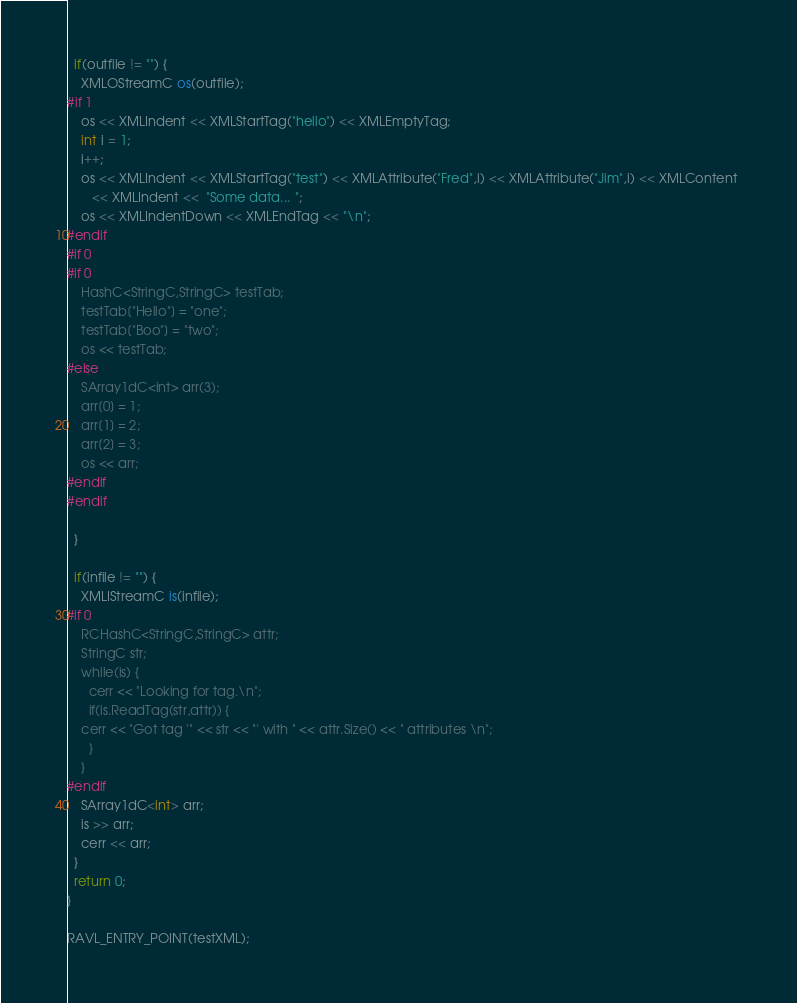<code> <loc_0><loc_0><loc_500><loc_500><_C++_>  if(outfile != "") {
    XMLOStreamC os(outfile);
#if 1
    os << XMLIndent << XMLStartTag("hello") << XMLEmptyTag;
    int i = 1;
    i++;
    os << XMLIndent << XMLStartTag("test") << XMLAttribute("Fred",i) << XMLAttribute("Jim",i) << XMLContent 
       << XMLIndent <<  "Some data... ";
    os << XMLIndentDown << XMLEndTag << "\n";
#endif    
#if 0
#if 0
    HashC<StringC,StringC> testTab;
    testTab["Hello"] = "one";
    testTab["Boo"] = "two";
    os << testTab;
#else
    SArray1dC<int> arr(3);
    arr[0] = 1;
    arr[1] = 2;
    arr[2] = 3;
    os << arr;
#endif
#endif

  }
  
  if(infile != "") {
    XMLIStreamC is(infile);
#if 0
    RCHashC<StringC,StringC> attr;
    StringC str;
    while(is) {
      cerr << "Looking for tag.\n";
      if(is.ReadTag(str,attr)) {
	cerr << "Got tag '" << str << "' with " << attr.Size() << " attributes \n";
      }
    }
#endif
    SArray1dC<int> arr;
    is >> arr;
    cerr << arr;
  }
  return 0;
}

RAVL_ENTRY_POINT(testXML);
</code> 